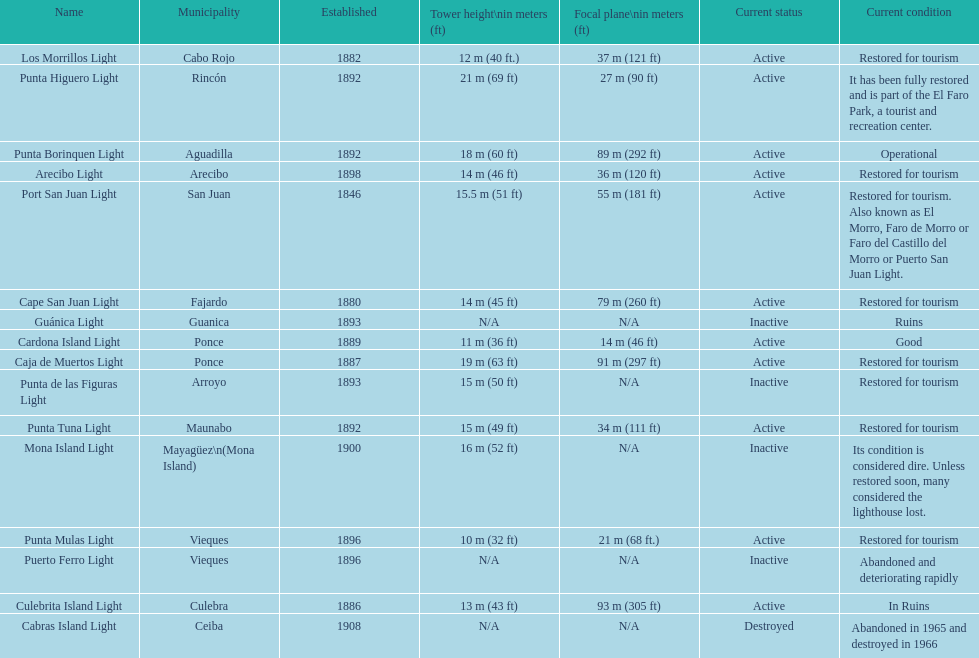Quantity of lighthouses commencing with the letter p 7. 